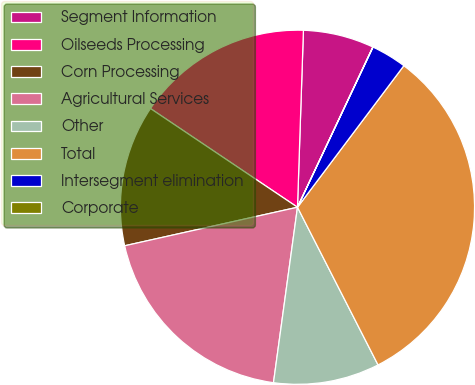Convert chart to OTSL. <chart><loc_0><loc_0><loc_500><loc_500><pie_chart><fcel>Segment Information<fcel>Oilseeds Processing<fcel>Corn Processing<fcel>Agricultural Services<fcel>Other<fcel>Total<fcel>Intersegment elimination<fcel>Corporate<nl><fcel>6.46%<fcel>16.12%<fcel>12.9%<fcel>19.34%<fcel>9.68%<fcel>32.22%<fcel>3.24%<fcel>0.02%<nl></chart> 